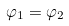<formula> <loc_0><loc_0><loc_500><loc_500>\varphi _ { 1 } = \varphi _ { 2 }</formula> 